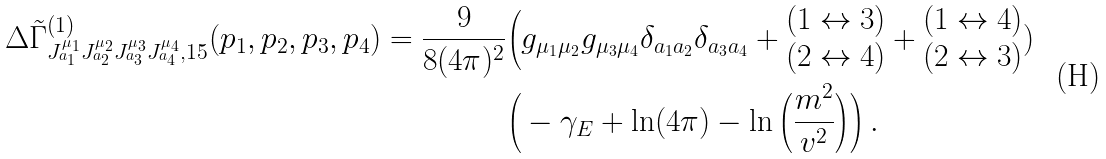<formula> <loc_0><loc_0><loc_500><loc_500>\, \Delta \tilde { \Gamma } ^ { ( 1 ) } _ { J ^ { \mu _ { 1 } } _ { a _ { 1 } } J ^ { \mu _ { 2 } } _ { a _ { 2 } } J ^ { \mu _ { 3 } } _ { a _ { 3 } } J ^ { \mu _ { 4 } } _ { a _ { 4 } } , 1 5 } ( p _ { 1 } , p _ { 2 } , p _ { 3 } , p _ { 4 } ) = \frac { 9 } { 8 ( 4 \pi ) ^ { 2 } } & \Big ( g _ { \mu _ { 1 } \mu _ { 2 } } g _ { \mu _ { 3 } \mu _ { 4 } } \delta _ { a _ { 1 } a _ { 2 } } \delta _ { a _ { 3 } a _ { 4 } } + { \begin{matrix} ( 1 \leftrightarrow 3 ) \\ ( 2 \leftrightarrow 4 ) \end{matrix} } + { \begin{matrix} ( 1 \leftrightarrow 4 ) \\ ( 2 \leftrightarrow 3 ) \end{matrix} } ) \\ & \Big ( - \gamma _ { E } + \ln ( 4 \pi ) - \ln \Big ( \frac { m ^ { 2 } } { v ^ { 2 } } \Big ) \Big ) \, .</formula> 